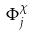Convert formula to latex. <formula><loc_0><loc_0><loc_500><loc_500>\Phi _ { j } ^ { \chi }</formula> 